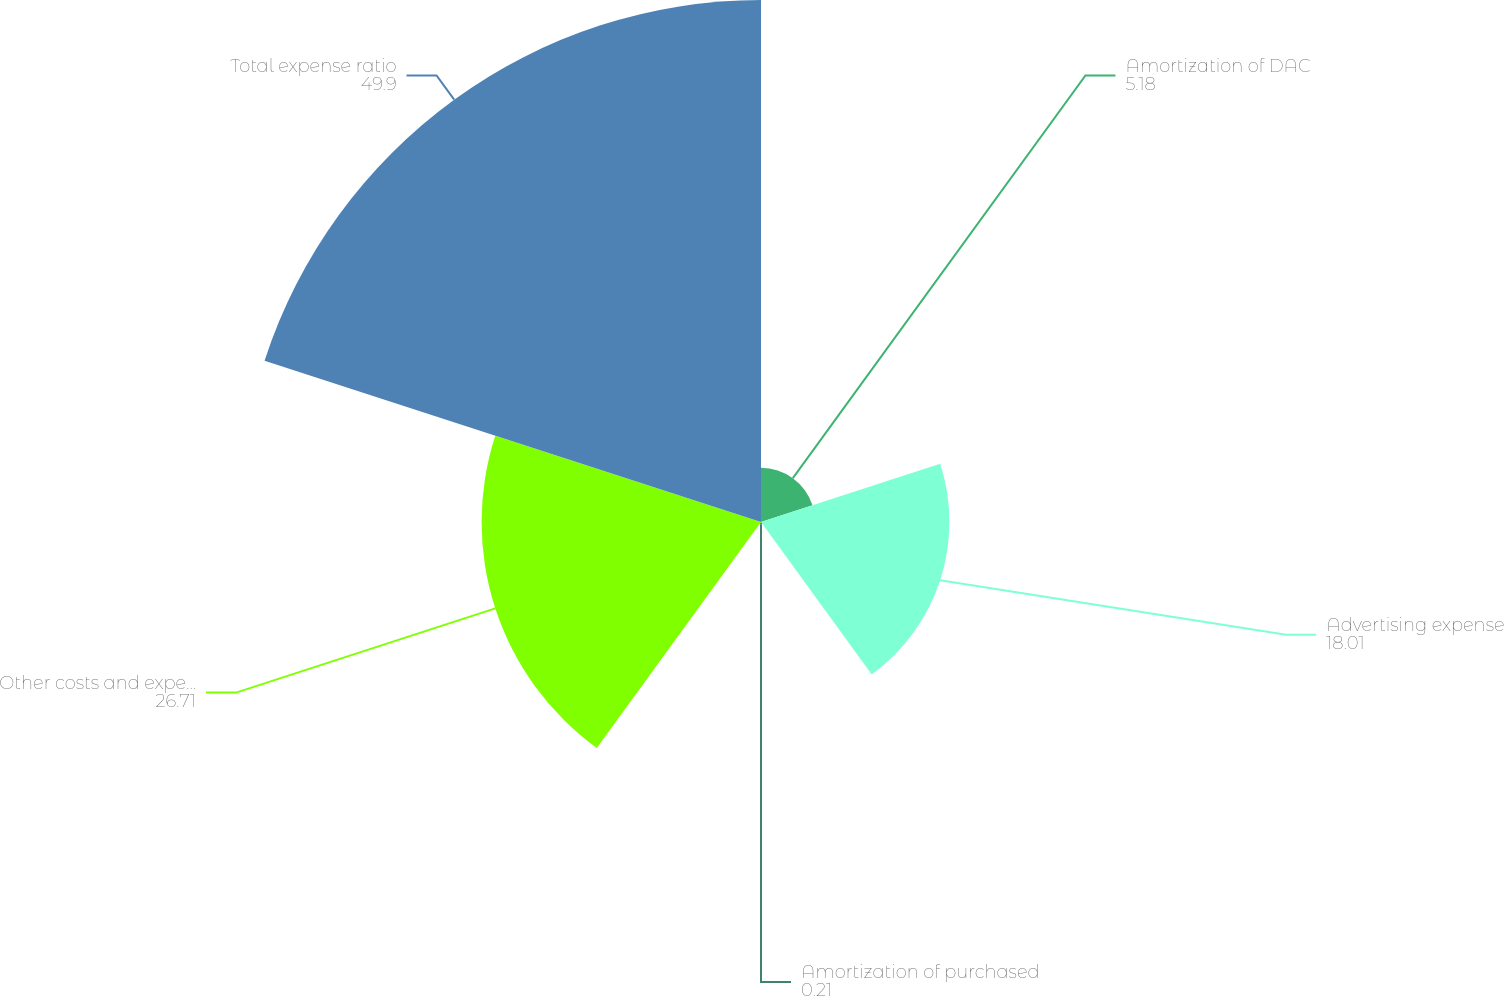Convert chart. <chart><loc_0><loc_0><loc_500><loc_500><pie_chart><fcel>Amortization of DAC<fcel>Advertising expense<fcel>Amortization of purchased<fcel>Other costs and expenses (1)<fcel>Total expense ratio<nl><fcel>5.18%<fcel>18.01%<fcel>0.21%<fcel>26.71%<fcel>49.9%<nl></chart> 